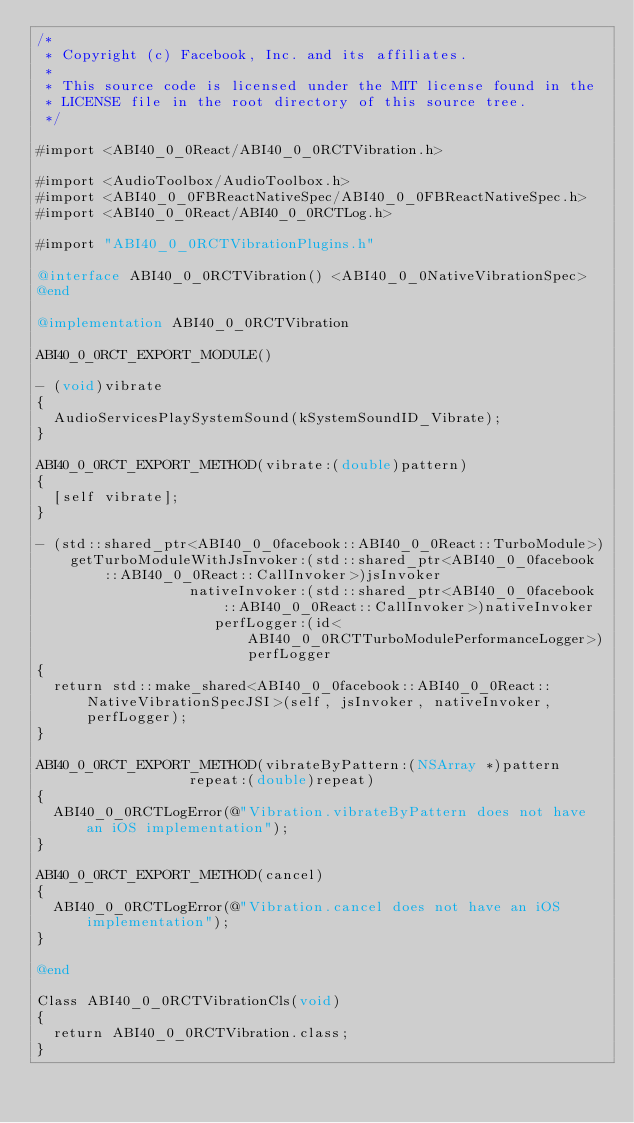Convert code to text. <code><loc_0><loc_0><loc_500><loc_500><_ObjectiveC_>/*
 * Copyright (c) Facebook, Inc. and its affiliates.
 *
 * This source code is licensed under the MIT license found in the
 * LICENSE file in the root directory of this source tree.
 */

#import <ABI40_0_0React/ABI40_0_0RCTVibration.h>

#import <AudioToolbox/AudioToolbox.h>
#import <ABI40_0_0FBReactNativeSpec/ABI40_0_0FBReactNativeSpec.h>
#import <ABI40_0_0React/ABI40_0_0RCTLog.h>

#import "ABI40_0_0RCTVibrationPlugins.h"

@interface ABI40_0_0RCTVibration() <ABI40_0_0NativeVibrationSpec>
@end

@implementation ABI40_0_0RCTVibration

ABI40_0_0RCT_EXPORT_MODULE()

- (void)vibrate
{
  AudioServicesPlaySystemSound(kSystemSoundID_Vibrate);
}

ABI40_0_0RCT_EXPORT_METHOD(vibrate:(double)pattern)
{
  [self vibrate];
}

- (std::shared_ptr<ABI40_0_0facebook::ABI40_0_0React::TurboModule>)
    getTurboModuleWithJsInvoker:(std::shared_ptr<ABI40_0_0facebook::ABI40_0_0React::CallInvoker>)jsInvoker
                  nativeInvoker:(std::shared_ptr<ABI40_0_0facebook::ABI40_0_0React::CallInvoker>)nativeInvoker
                     perfLogger:(id<ABI40_0_0RCTTurboModulePerformanceLogger>)perfLogger
{
  return std::make_shared<ABI40_0_0facebook::ABI40_0_0React::NativeVibrationSpecJSI>(self, jsInvoker, nativeInvoker, perfLogger);
}

ABI40_0_0RCT_EXPORT_METHOD(vibrateByPattern:(NSArray *)pattern
                  repeat:(double)repeat)
{
  ABI40_0_0RCTLogError(@"Vibration.vibrateByPattern does not have an iOS implementation");
}

ABI40_0_0RCT_EXPORT_METHOD(cancel)
{
  ABI40_0_0RCTLogError(@"Vibration.cancel does not have an iOS implementation");
}

@end

Class ABI40_0_0RCTVibrationCls(void)
{
  return ABI40_0_0RCTVibration.class;
}
</code> 